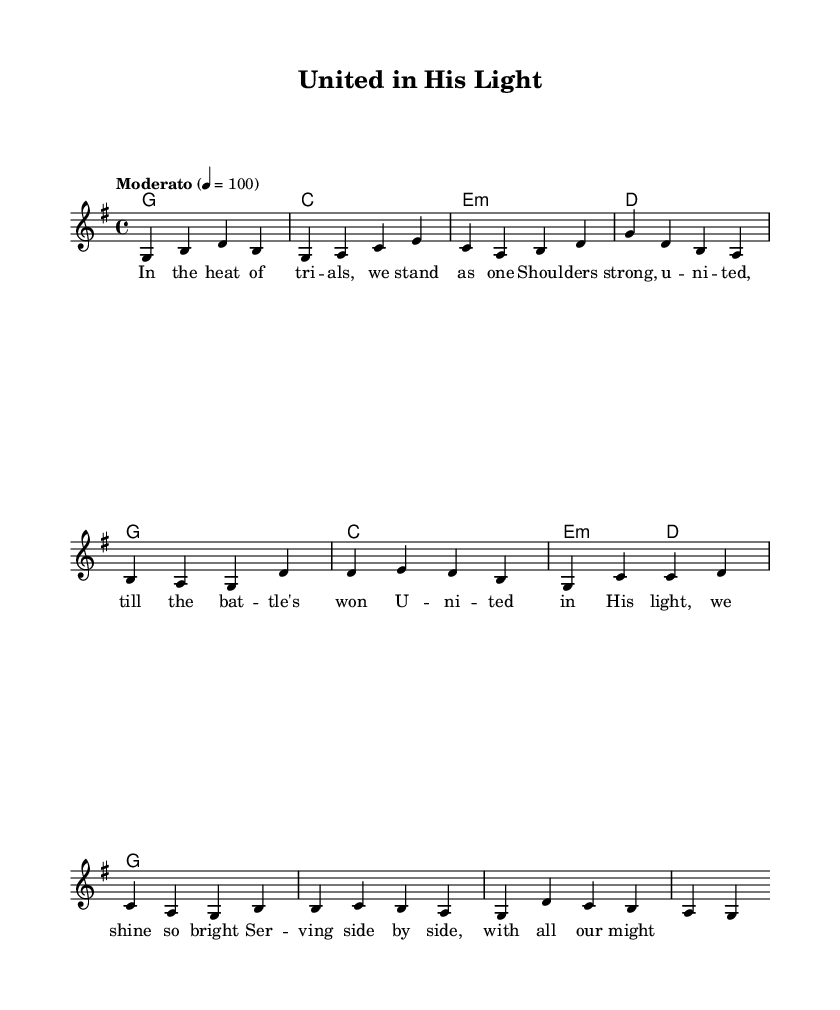What is the key signature of this music? The key signature is G major, which has one sharp (F#) indicated by the presence of the note F# in the melody.
Answer: G major What is the time signature of this piece? The time signature is represented by the notation "4/4" at the beginning of the music, indicating four beats per measure.
Answer: 4/4 What is the tempo marking for the song? The tempo marking "Moderato" with a metronome marking of 4 = 100 indicates a moderate pace at a speed of 100 beats per minute.
Answer: Moderato How many measures are in the verse section? The verse is divided into four measures, as indicated by the grouping of notes and harmonies assigned to the verse lyrics.
Answer: 4 What is the root chord of the first measure? The first measure shows the harmony 'g1', which identifies the root chord as G major.
Answer: G What is the lyrical theme of the song? The lyrics focus on unity, strength, and community, emphasizing standing together during trials and serving side by side in faith.
Answer: Unity What is the final chord in the chorus? The final chord in the chorus is 'g1', indicating that it resolves back to G major, which is often used for endings.
Answer: G 